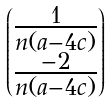Convert formula to latex. <formula><loc_0><loc_0><loc_500><loc_500>\begin{pmatrix} \frac { 1 } { n ( a - 4 c ) } \\ \frac { - 2 } { n ( a - 4 c ) } \end{pmatrix}</formula> 